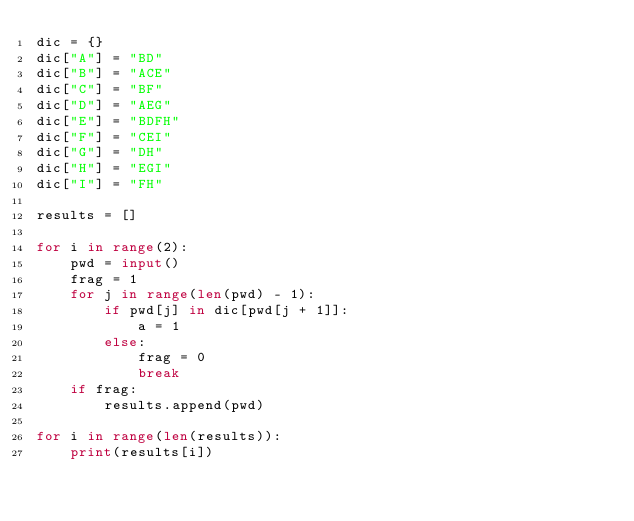<code> <loc_0><loc_0><loc_500><loc_500><_Python_>dic = {}
dic["A"] = "BD"
dic["B"] = "ACE"
dic["C"] = "BF"
dic["D"] = "AEG"
dic["E"] = "BDFH"
dic["F"] = "CEI"
dic["G"] = "DH"
dic["H"] = "EGI"
dic["I"] = "FH"

results = []

for i in range(2):
	pwd = input()
	frag = 1
	for j in range(len(pwd) - 1):
		if pwd[j] in dic[pwd[j + 1]]:
			a = 1
		else:
			frag = 0
			break
	if frag:
		results.append(pwd)

for i in range(len(results)):
	print(results[i])</code> 